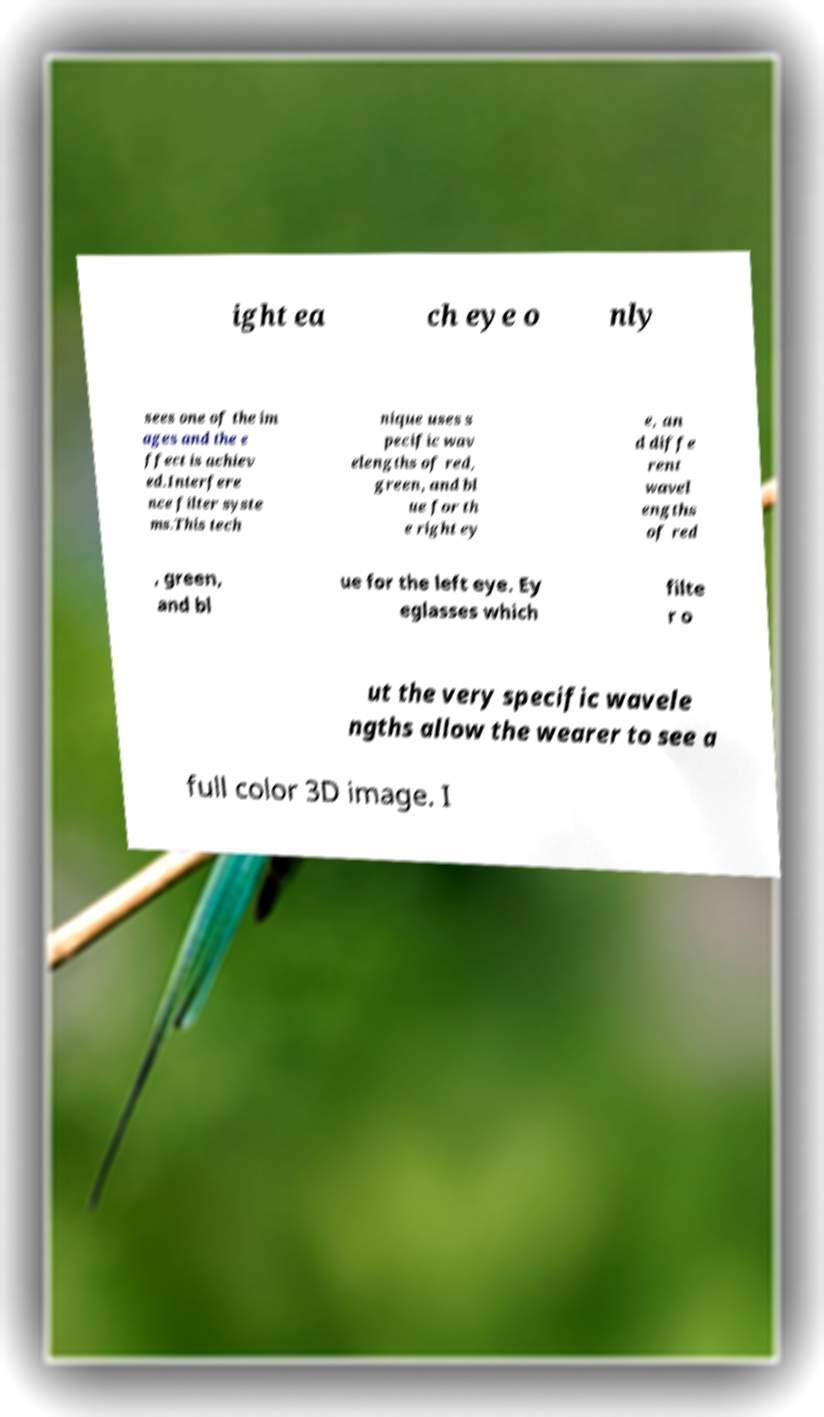I need the written content from this picture converted into text. Can you do that? ight ea ch eye o nly sees one of the im ages and the e ffect is achiev ed.Interfere nce filter syste ms.This tech nique uses s pecific wav elengths of red, green, and bl ue for th e right ey e, an d diffe rent wavel engths of red , green, and bl ue for the left eye. Ey eglasses which filte r o ut the very specific wavele ngths allow the wearer to see a full color 3D image. I 